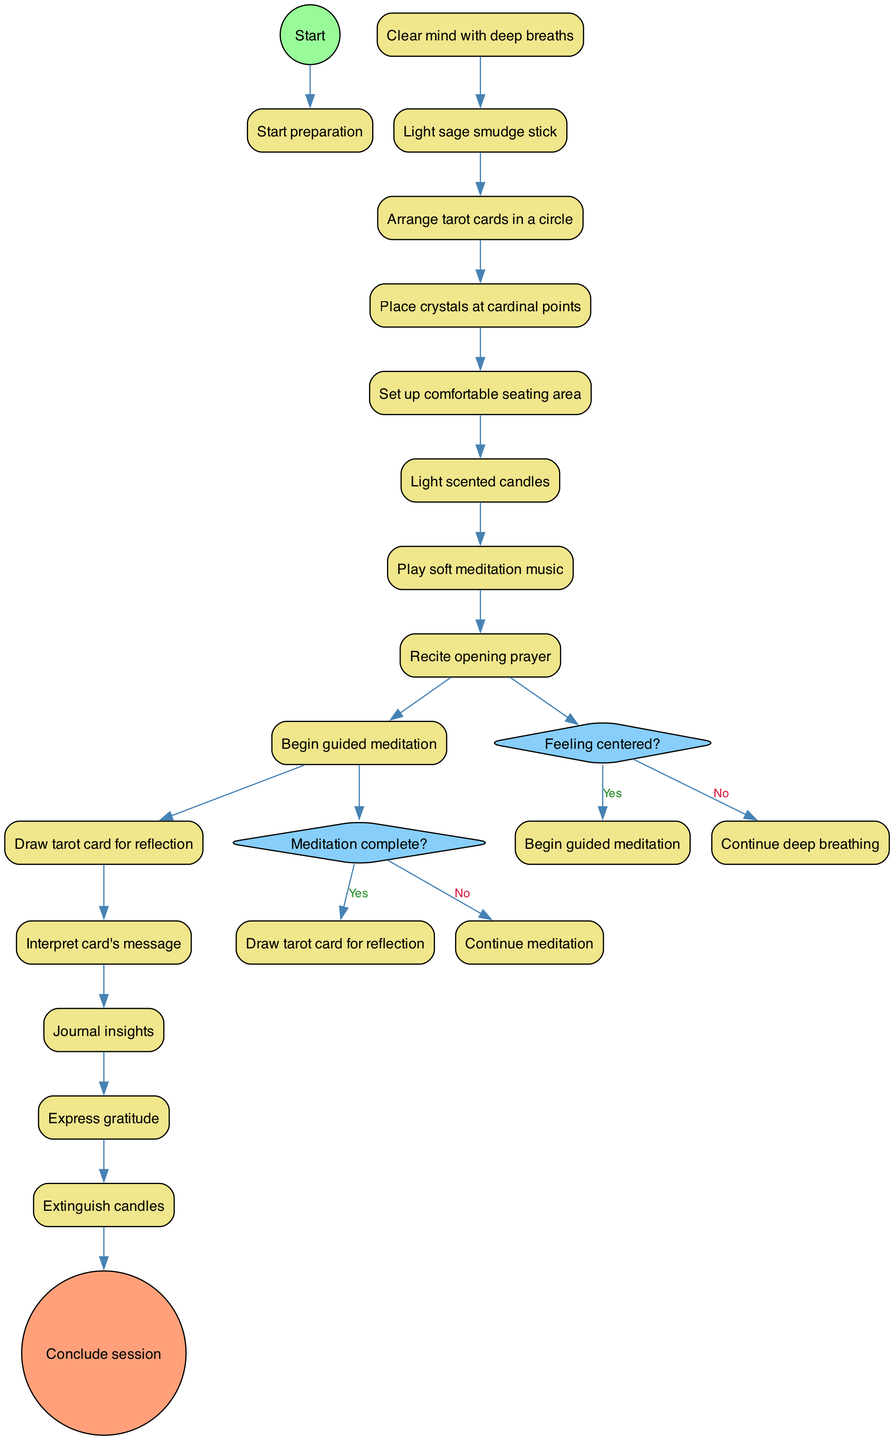What is the first activity in the diagram? The first activity listed in the diagram is "Clear mind with deep breaths," which follows the initial preparation step.
Answer: Clear mind with deep breaths How many activities are there in total? The diagram lists 14 activities from "Clear mind with deep breaths" through to "Extinguish candles," which counts up to a total of 14 activities.
Answer: 14 What happens if the answer to "Feeling centered?" is 'No'? If the answer to "Feeling centered?" is 'No', the diagram indicates that one should "Continue deep breathing" before trying to begin the guided meditation.
Answer: Continue deep breathing What is the activity after "Recite opening prayer"? Following "Recite opening prayer," the next activity presented in the diagram is "Begin guided meditation."
Answer: Begin guided meditation Which activity is followed by the change to "Draw tarot card for reflection"? The activity that comes right before "Draw tarot card for reflection" is "Meditation complete?" If the answer to that decision is 'Yes', then the flow proceeds to drawing a tarot card.
Answer: Meditation complete? What is the final activity before concluding the session? The last activity before concluding the session according to the diagram is "Express gratitude," which signifies the final reflective step in the meditation process.
Answer: Express gratitude What decision follows the activity "Begin guided meditation"? After "Begin guided meditation," the decision point is "Meditation complete?" which determines the next steps based on the status of the meditation.
Answer: Meditation complete? How is the decision about whether to continue meditation structured in the diagram? The decision about continuing meditation is a binary choice where the flow can either proceed to "Draw tarot card for reflection" if 'Yes', or loop back to "Continue meditation" if 'No'.
Answer: Binary choice What is the shape of the nodes representing decisions? The nodes that represent decisions in this diagram are shaped like diamonds, which is a standard representation for decision points in activity diagrams.
Answer: Diamond 